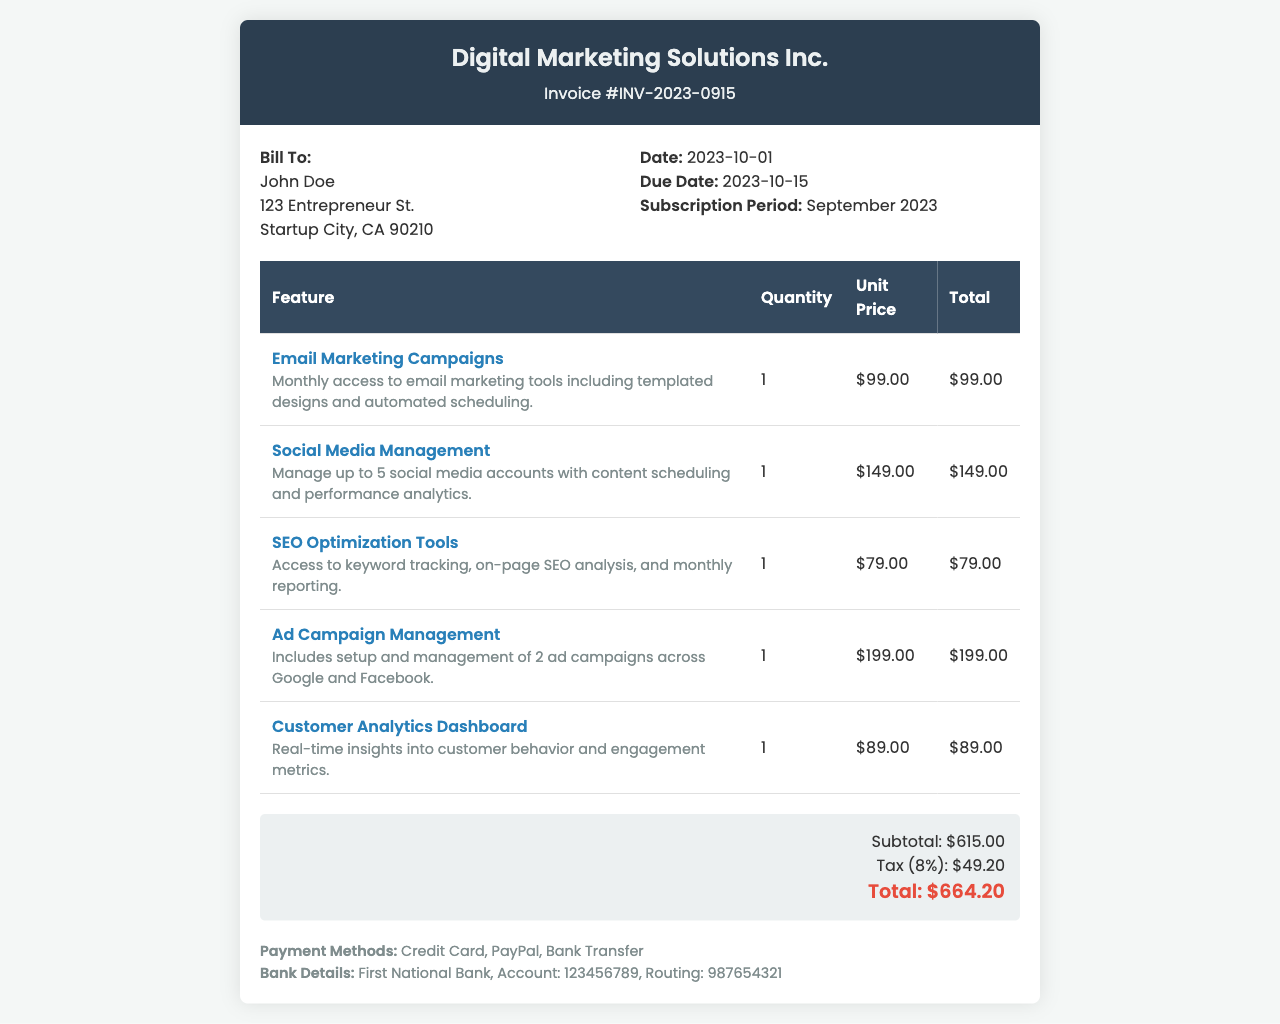What is the invoice number? The invoice number is clearly stated in the header of the document, labeled as "Invoice #".
Answer: INV-2023-0915 Who is the invoice billed to? The "Bill To" section provides the name of the individual or entity the invoice is addressed to.
Answer: John Doe What is the total amount due? The total amount due is shown at the bottom of the invoice within the summary section.
Answer: $664.20 What is the due date for the payment? The due date is specified in the invoice details section, indicating when the payment is required.
Answer: 2023-10-15 How many features are listed in the invoice? The features are itemized in a table, and the total count can be determined by counting the rows in that section.
Answer: 5 What is the unit price of the Ad Campaign Management feature? The unit price is found in the invoice table next to the related feature.
Answer: $199.00 What is the tax rate applied on the invoice? The tax amount is provided in the summary, and the tax rate can be deduced from the values given.
Answer: 8% What payment methods are accepted? The payment methods are explicitly listed in the payment methods section of the document.
Answer: Credit Card, PayPal, Bank Transfer What is the subtotal before tax? The subtotal is displayed separately in the summary section above the tax calculation.
Answer: $615.00 